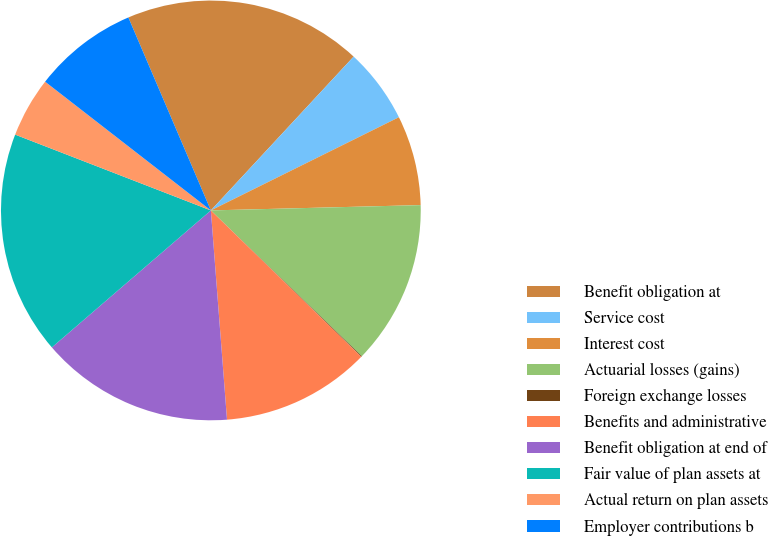Convert chart to OTSL. <chart><loc_0><loc_0><loc_500><loc_500><pie_chart><fcel>Benefit obligation at<fcel>Service cost<fcel>Interest cost<fcel>Actuarial losses (gains)<fcel>Foreign exchange losses<fcel>Benefits and administrative<fcel>Benefit obligation at end of<fcel>Fair value of plan assets at<fcel>Actual return on plan assets<fcel>Employer contributions b<nl><fcel>18.34%<fcel>5.77%<fcel>6.92%<fcel>12.63%<fcel>0.06%<fcel>11.49%<fcel>14.91%<fcel>17.2%<fcel>4.63%<fcel>8.06%<nl></chart> 